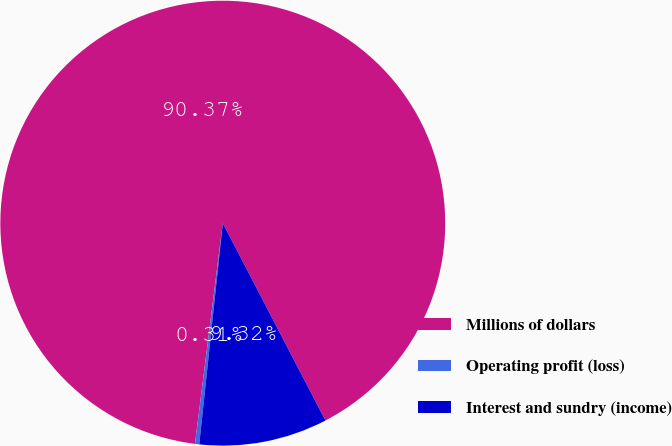Convert chart to OTSL. <chart><loc_0><loc_0><loc_500><loc_500><pie_chart><fcel>Millions of dollars<fcel>Operating profit (loss)<fcel>Interest and sundry (income)<nl><fcel>90.37%<fcel>0.31%<fcel>9.32%<nl></chart> 